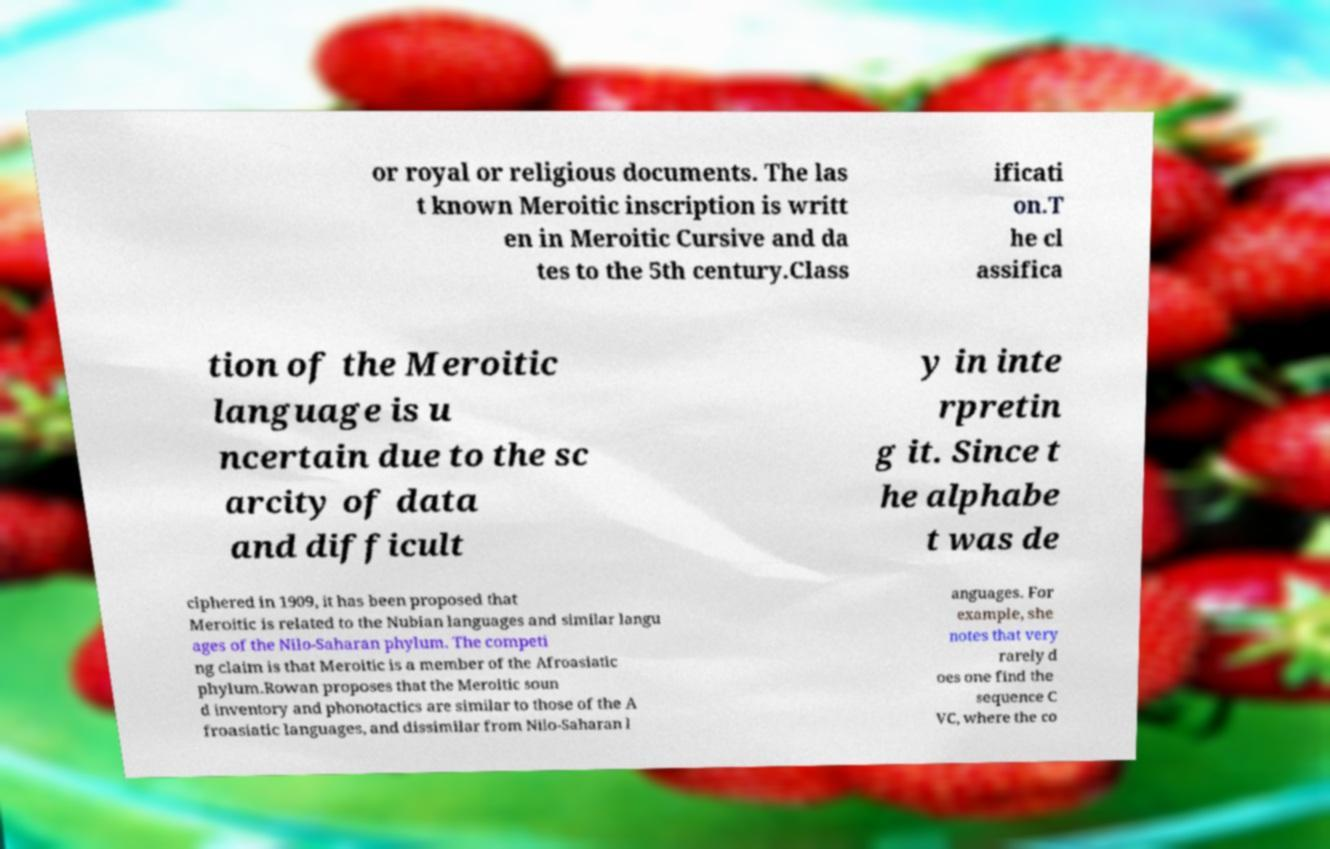Can you read and provide the text displayed in the image?This photo seems to have some interesting text. Can you extract and type it out for me? or royal or religious documents. The las t known Meroitic inscription is writt en in Meroitic Cursive and da tes to the 5th century.Class ificati on.T he cl assifica tion of the Meroitic language is u ncertain due to the sc arcity of data and difficult y in inte rpretin g it. Since t he alphabe t was de ciphered in 1909, it has been proposed that Meroitic is related to the Nubian languages and similar langu ages of the Nilo-Saharan phylum. The competi ng claim is that Meroitic is a member of the Afroasiatic phylum.Rowan proposes that the Meroitic soun d inventory and phonotactics are similar to those of the A froasiatic languages, and dissimilar from Nilo-Saharan l anguages. For example, she notes that very rarely d oes one find the sequence C VC, where the co 